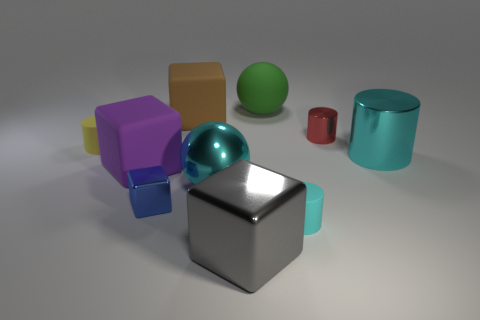Subtract all tiny blue metal cubes. How many cubes are left? 3 Subtract all purple cubes. How many cubes are left? 3 Subtract 0 yellow blocks. How many objects are left? 10 Subtract all cylinders. How many objects are left? 6 Subtract 2 cubes. How many cubes are left? 2 Subtract all gray spheres. Subtract all blue cylinders. How many spheres are left? 2 Subtract all cyan cylinders. How many cyan balls are left? 1 Subtract all large red matte cubes. Subtract all blue things. How many objects are left? 9 Add 9 big rubber balls. How many big rubber balls are left? 10 Add 9 brown blocks. How many brown blocks exist? 10 